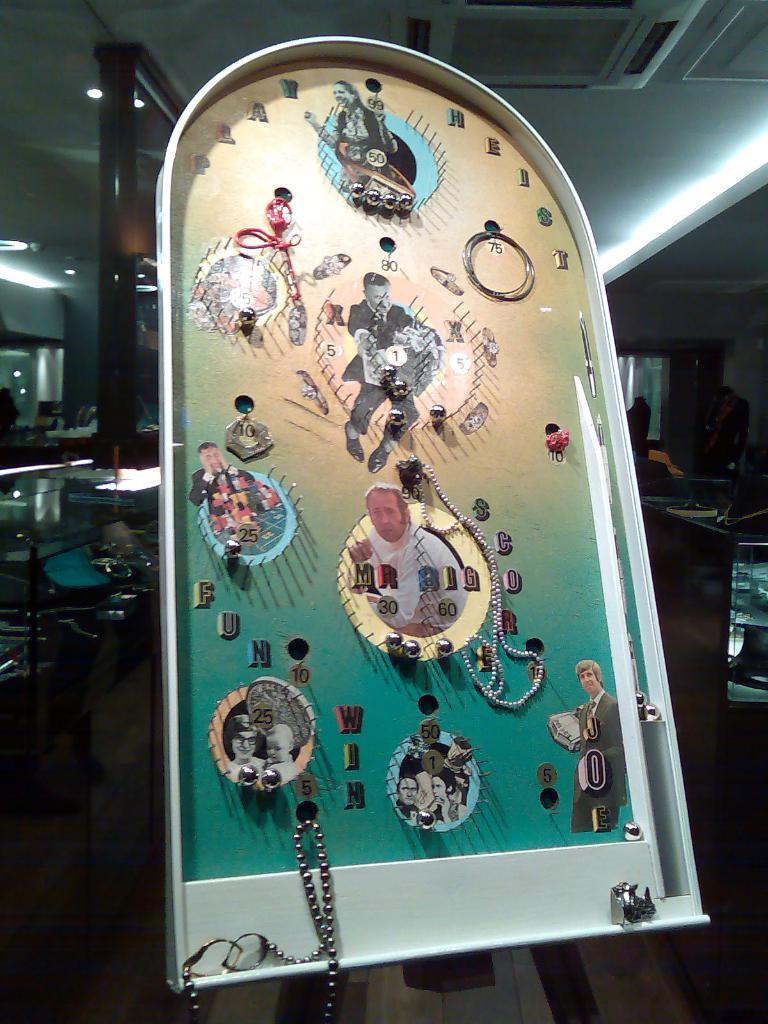How would you summarize this image in a sentence or two? This is a game board. On the background of the picture we can see tables. This is a ceiling. This is a central AC. this is a floor. 